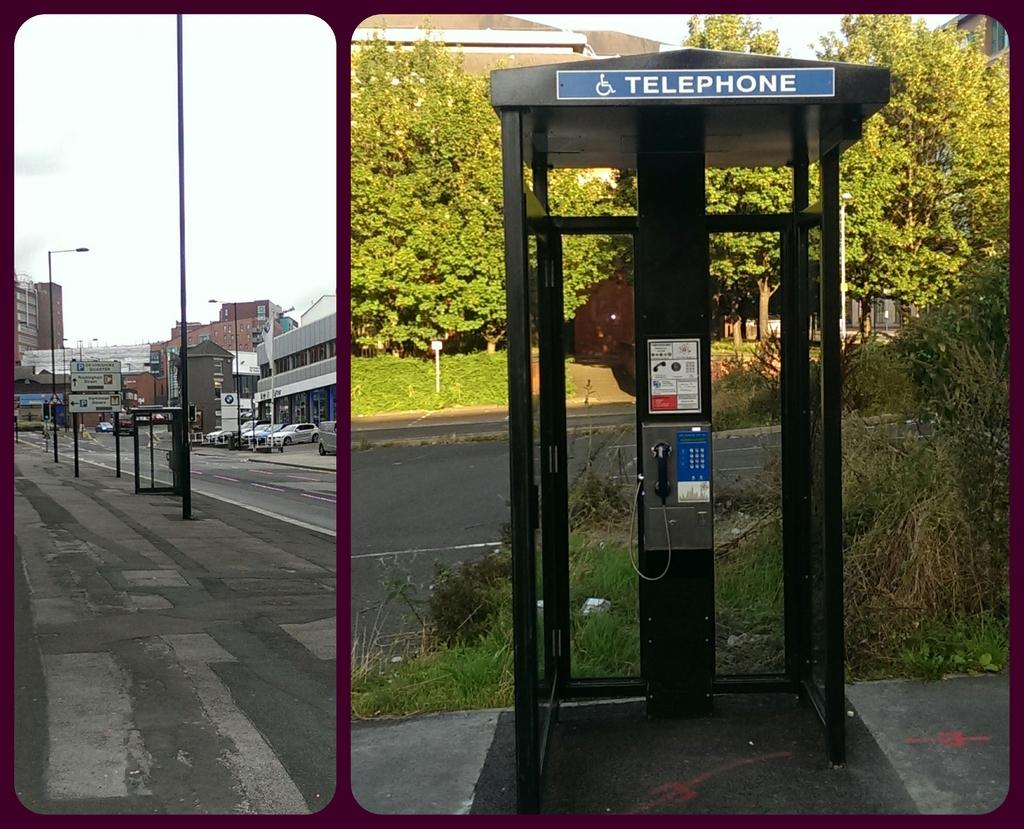<image>
Offer a succinct explanation of the picture presented. a close up of an old Telephone booth in an abandoned street 